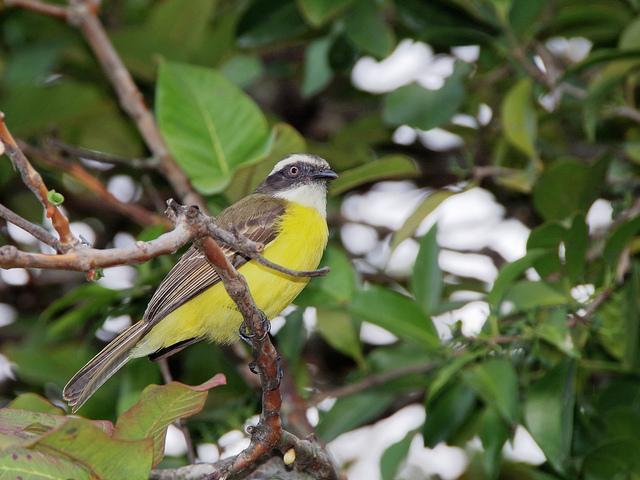How many birds are there?
Give a very brief answer. 1. How many people are sitting in this scene?
Give a very brief answer. 0. 